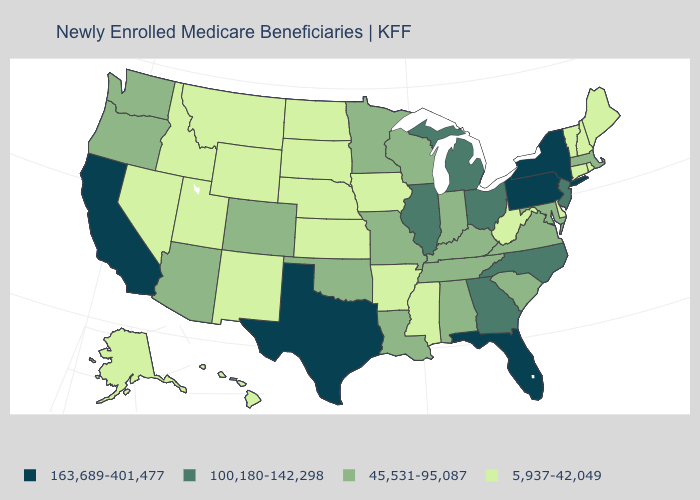Does Mississippi have the lowest value in the USA?
Concise answer only. Yes. Is the legend a continuous bar?
Answer briefly. No. Does California have the highest value in the USA?
Quick response, please. Yes. Which states have the lowest value in the South?
Keep it brief. Arkansas, Delaware, Mississippi, West Virginia. Does Minnesota have a lower value than Kentucky?
Be succinct. No. Does Vermont have the highest value in the USA?
Answer briefly. No. Does Nebraska have the highest value in the USA?
Quick response, please. No. Which states have the highest value in the USA?
Quick response, please. California, Florida, New York, Pennsylvania, Texas. Which states hav the highest value in the Northeast?
Write a very short answer. New York, Pennsylvania. How many symbols are there in the legend?
Answer briefly. 4. What is the highest value in states that border Oklahoma?
Concise answer only. 163,689-401,477. Does the map have missing data?
Be succinct. No. Does New York have the highest value in the Northeast?
Concise answer only. Yes. What is the value of Massachusetts?
Give a very brief answer. 45,531-95,087. Which states have the highest value in the USA?
Answer briefly. California, Florida, New York, Pennsylvania, Texas. 